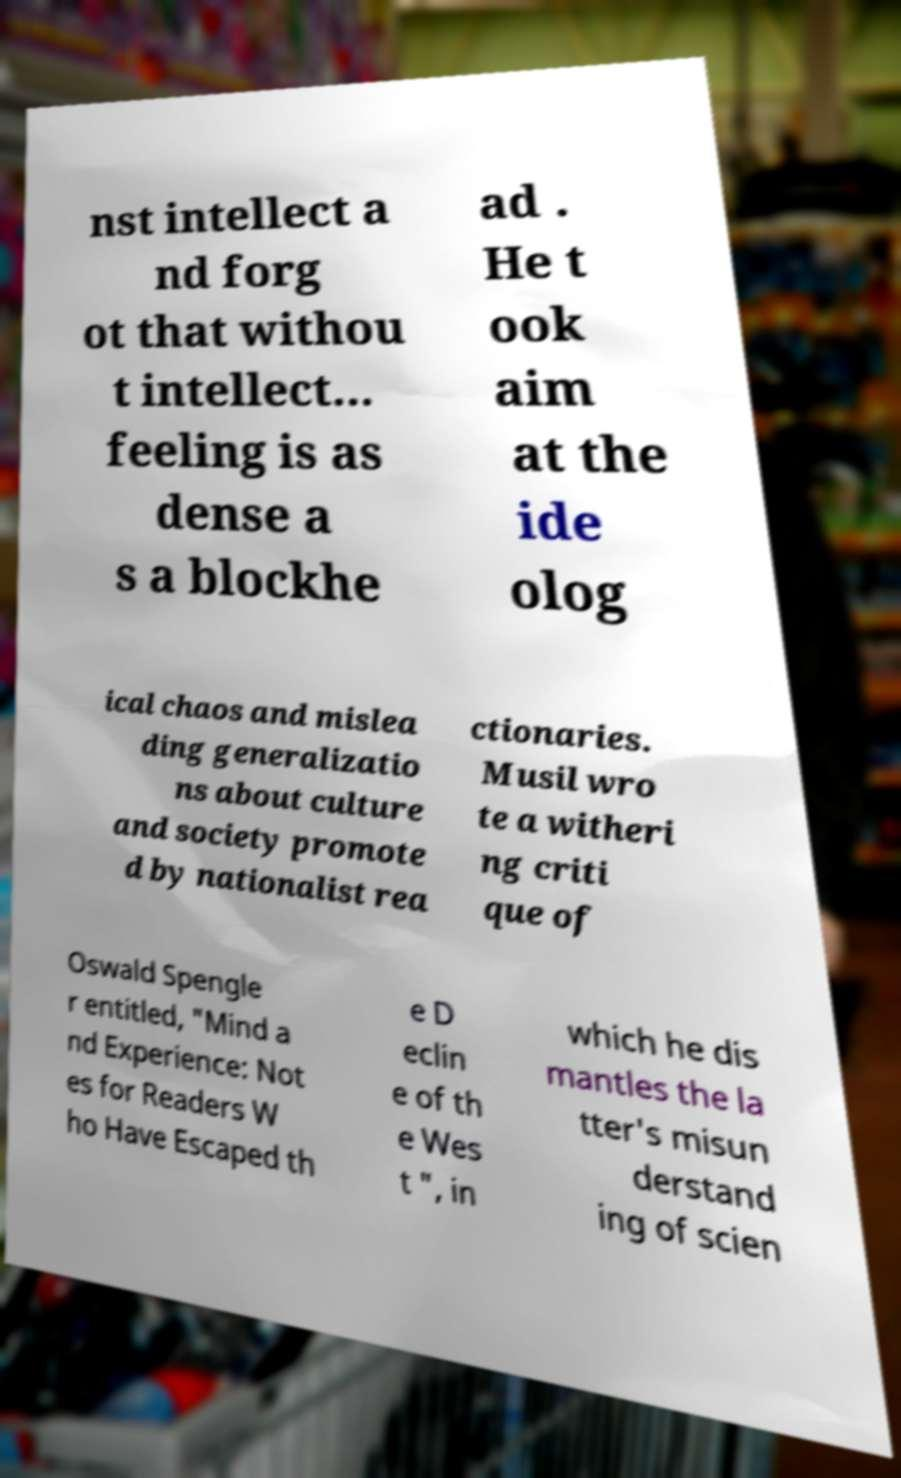I need the written content from this picture converted into text. Can you do that? nst intellect a nd forg ot that withou t intellect... feeling is as dense a s a blockhe ad . He t ook aim at the ide olog ical chaos and mislea ding generalizatio ns about culture and society promote d by nationalist rea ctionaries. Musil wro te a witheri ng criti que of Oswald Spengle r entitled, "Mind a nd Experience: Not es for Readers W ho Have Escaped th e D eclin e of th e Wes t ", in which he dis mantles the la tter's misun derstand ing of scien 